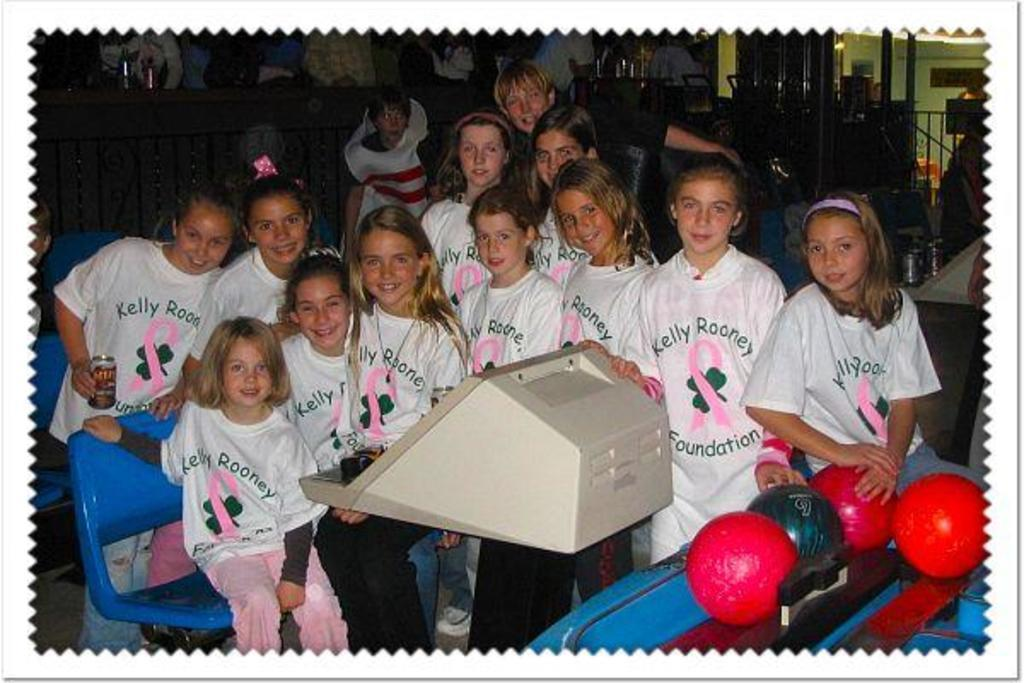What is the main subject of the image? The main subject of the image is a group of girls. What are the girls doing in the image? Some girls are sitting on chairs, while others are standing. What is the facial expression of the girls in the image? The girls are smiling. What objects can be seen in the image besides the girls? There are balls and a machine in the image. What can be seen in the background of the image? There are objects visible in the background. What is the sister of the girl in the image doing during the summer? There is no mention of a sister or summer in the image, so it is not possible to answer that question. 